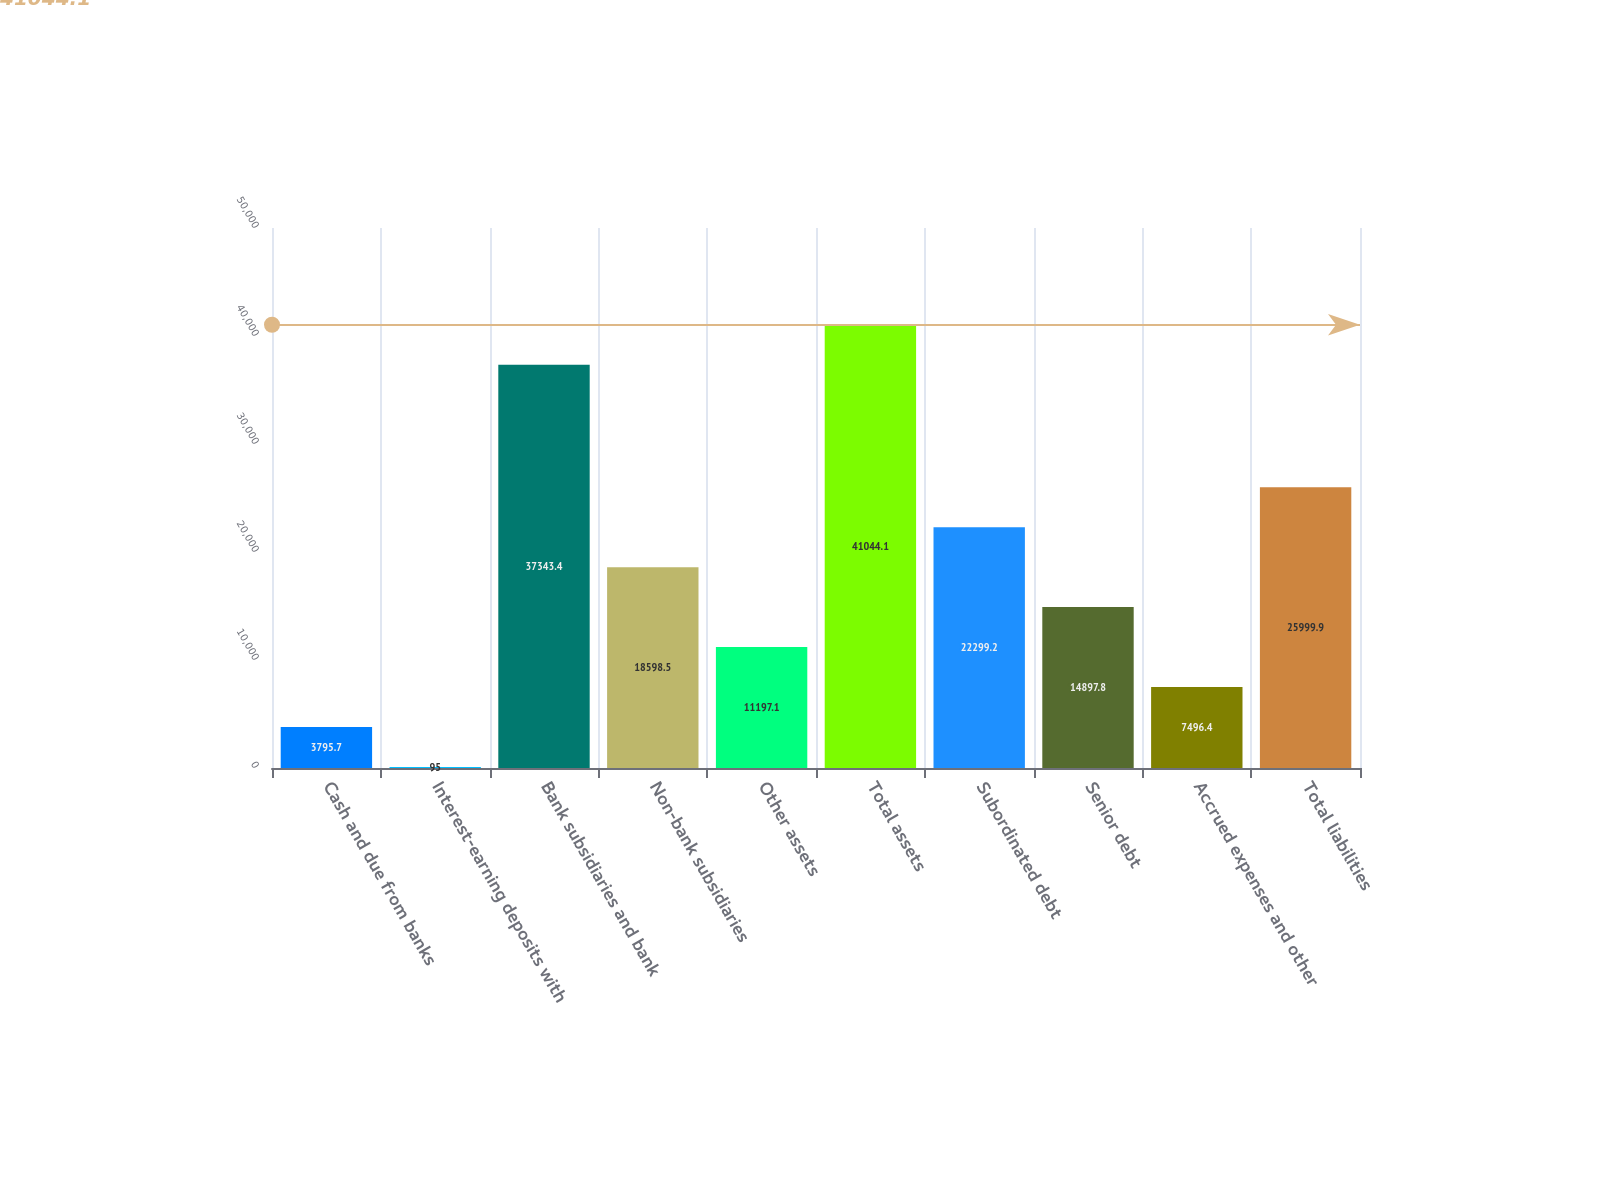Convert chart to OTSL. <chart><loc_0><loc_0><loc_500><loc_500><bar_chart><fcel>Cash and due from banks<fcel>Interest-earning deposits with<fcel>Bank subsidiaries and bank<fcel>Non-bank subsidiaries<fcel>Other assets<fcel>Total assets<fcel>Subordinated debt<fcel>Senior debt<fcel>Accrued expenses and other<fcel>Total liabilities<nl><fcel>3795.7<fcel>95<fcel>37343.4<fcel>18598.5<fcel>11197.1<fcel>41044.1<fcel>22299.2<fcel>14897.8<fcel>7496.4<fcel>25999.9<nl></chart> 